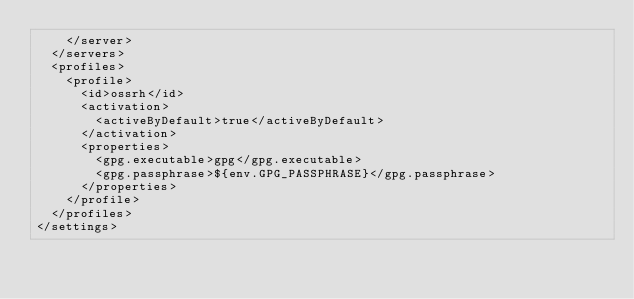Convert code to text. <code><loc_0><loc_0><loc_500><loc_500><_XML_>		</server>
	</servers>
	<profiles>
		<profile>
			<id>ossrh</id>
			<activation>
				<activeByDefault>true</activeByDefault>
			</activation>
			<properties>
				<gpg.executable>gpg</gpg.executable>
				<gpg.passphrase>${env.GPG_PASSPHRASE}</gpg.passphrase>
			</properties>
		</profile>
	</profiles>
</settings>
</code> 